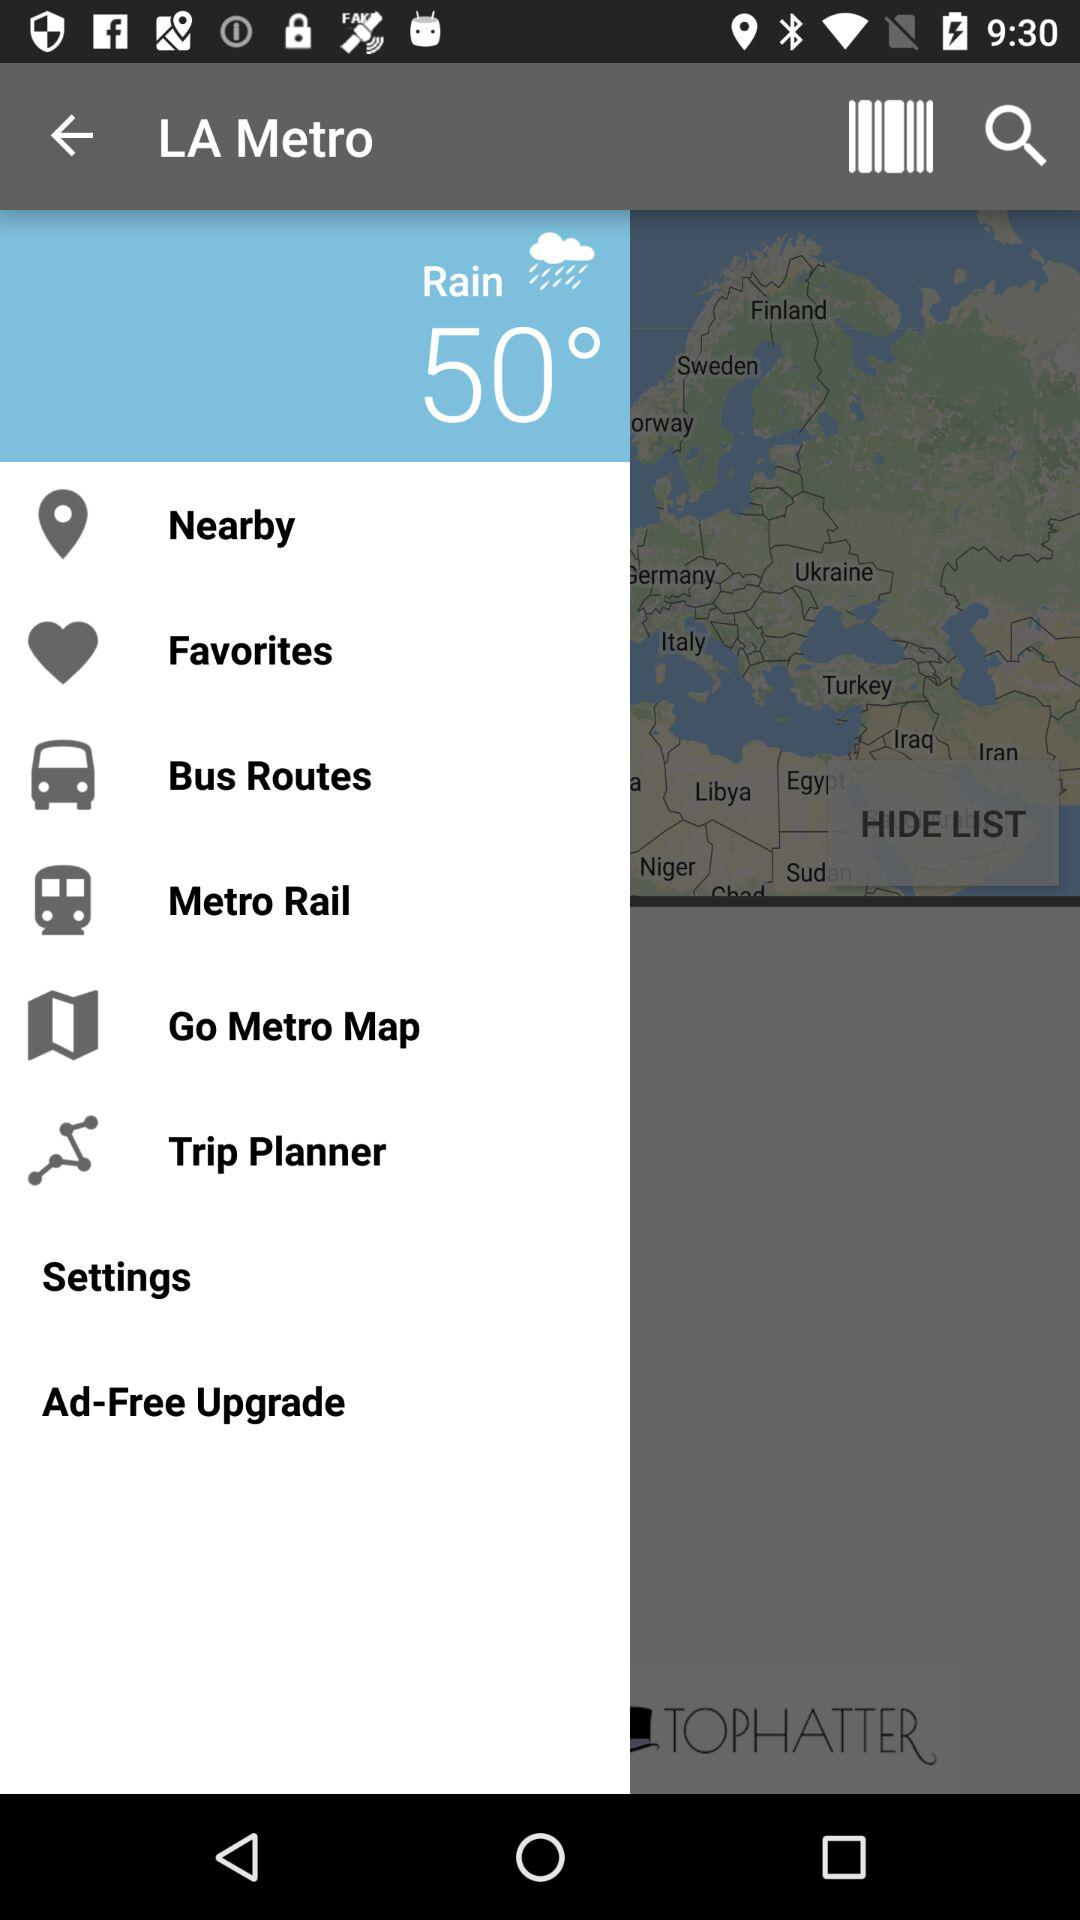What is the unit of temperature? The unit of temperature is a degree. 